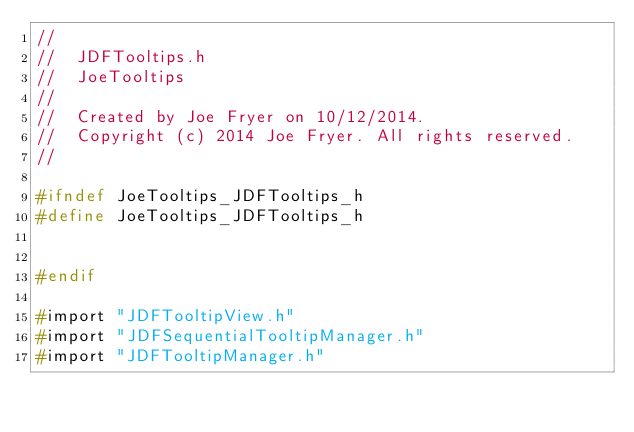Convert code to text. <code><loc_0><loc_0><loc_500><loc_500><_C_>//
//  JDFTooltips.h
//  JoeTooltips
//
//  Created by Joe Fryer on 10/12/2014.
//  Copyright (c) 2014 Joe Fryer. All rights reserved.
//

#ifndef JoeTooltips_JDFTooltips_h
#define JoeTooltips_JDFTooltips_h


#endif

#import "JDFTooltipView.h"
#import "JDFSequentialTooltipManager.h"
#import "JDFTooltipManager.h"
</code> 